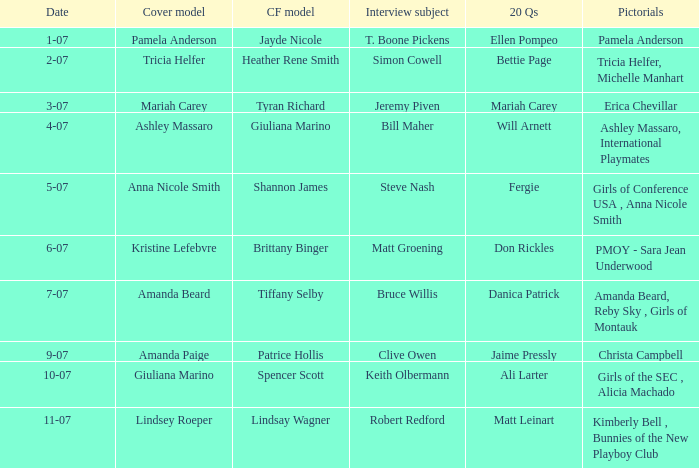Who was the centerfold model when the issue's pictorial was amanda beard, reby sky , girls of montauk ? Tiffany Selby. 